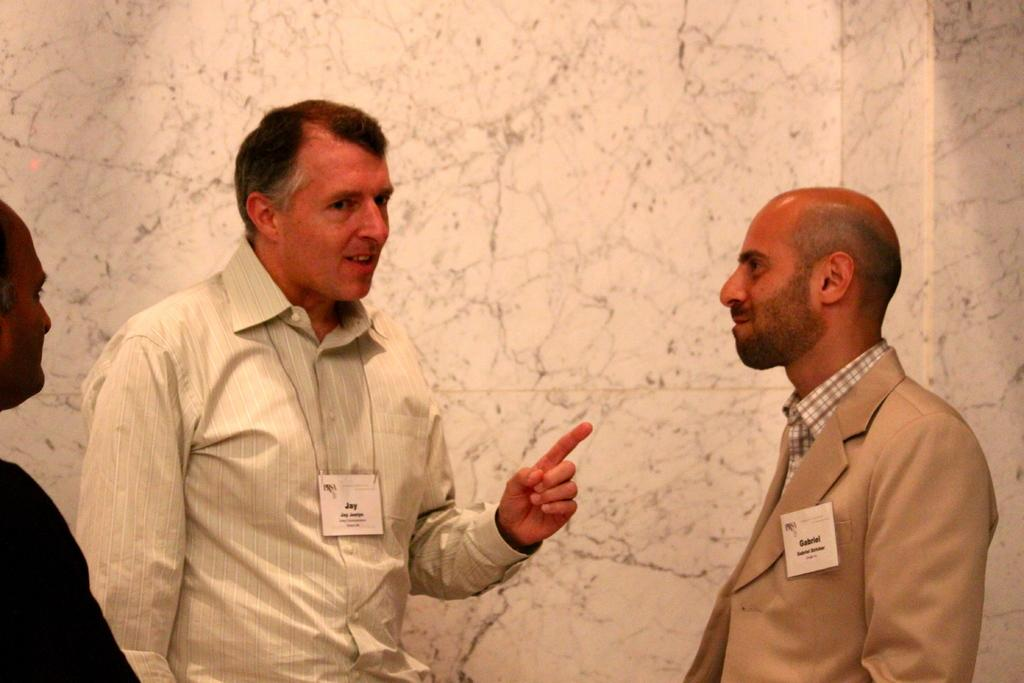How many men are present in the image? There are three men in the image. What are the men wearing that is visible in the image? The men are wearing tags. What is visible in the background of the image? There is a wall in the background of the image. What is the weight of the spark that can be seen in the yard in the image? There is no spark or yard present in the image; it features three men wearing tags. 